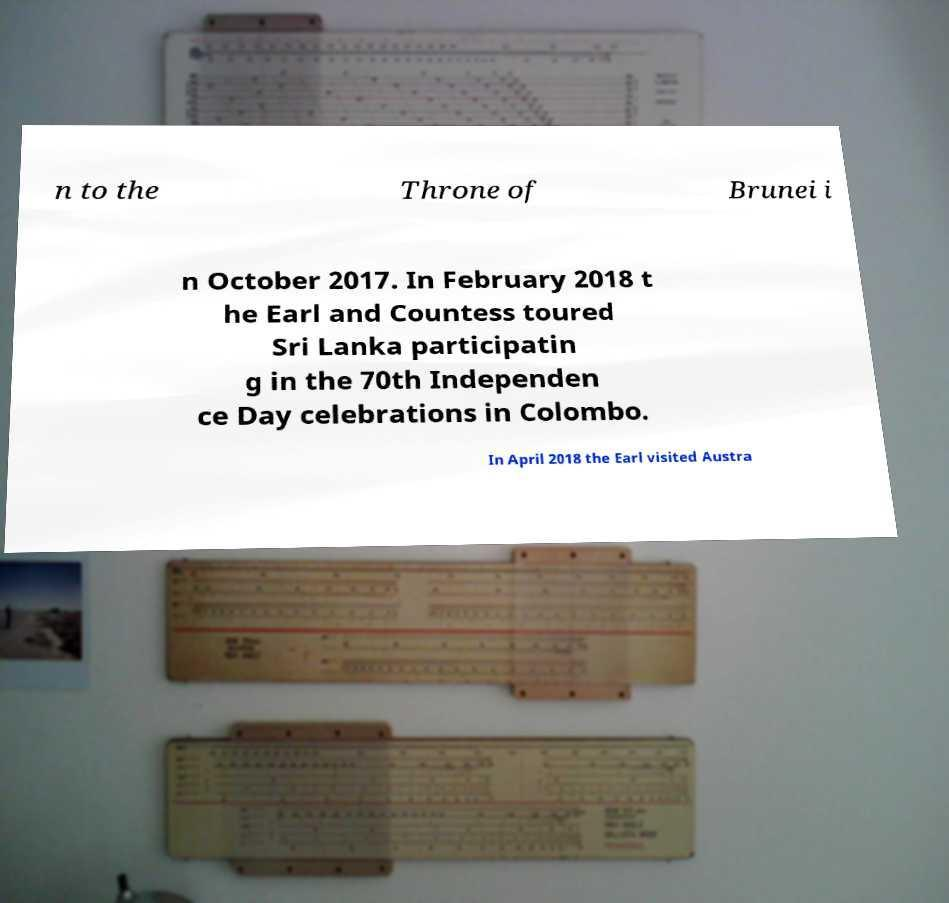What messages or text are displayed in this image? I need them in a readable, typed format. n to the Throne of Brunei i n October 2017. In February 2018 t he Earl and Countess toured Sri Lanka participatin g in the 70th Independen ce Day celebrations in Colombo. In April 2018 the Earl visited Austra 